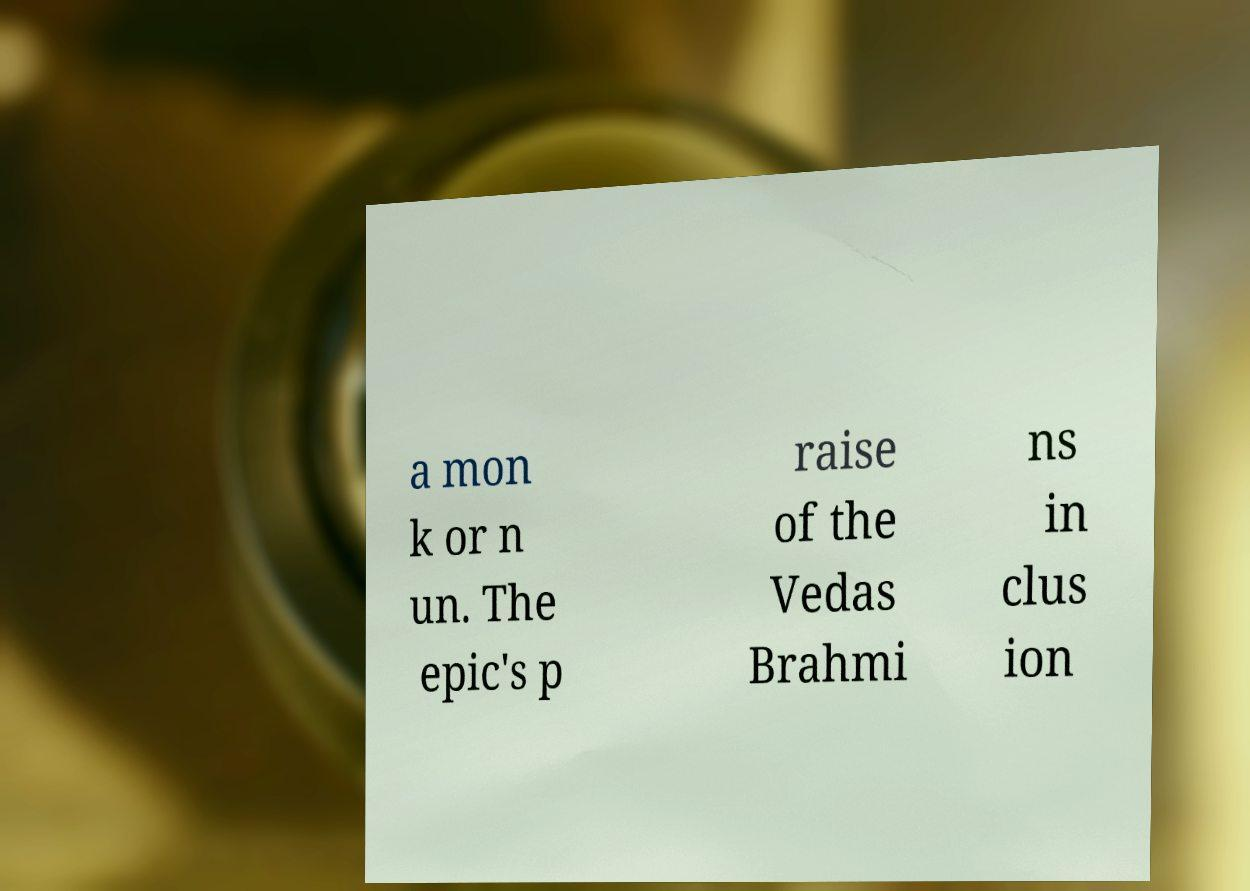Please read and relay the text visible in this image. What does it say? a mon k or n un. The epic's p raise of the Vedas Brahmi ns in clus ion 